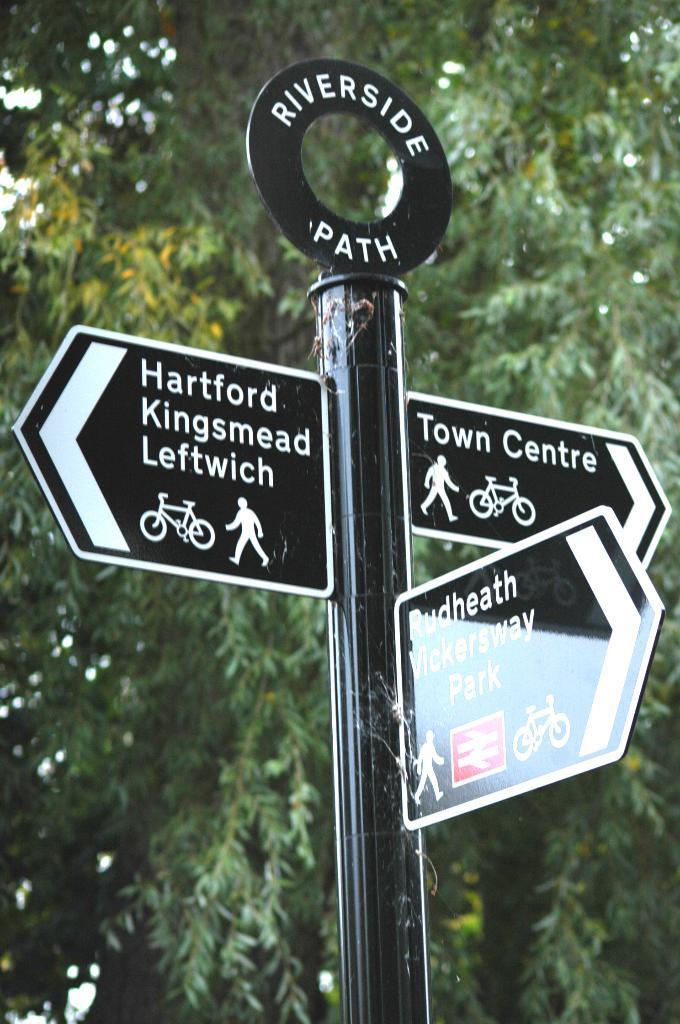Can you describe this image briefly? In this image I can see the black color pole and there are three broads to it. And I can see something is written on it. In the background I can see many trees. 